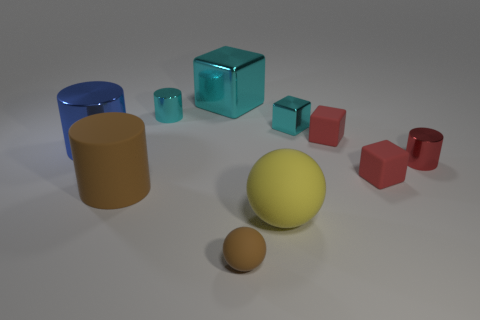Subtract all red cylinders. How many red blocks are left? 2 Subtract 2 cubes. How many cubes are left? 2 Subtract all brown cylinders. How many cylinders are left? 3 Subtract all cyan shiny cylinders. How many cylinders are left? 3 Subtract all green cylinders. Subtract all gray balls. How many cylinders are left? 4 Subtract all balls. How many objects are left? 8 Add 1 tiny cyan metal cylinders. How many tiny cyan metal cylinders exist? 2 Subtract 0 gray cylinders. How many objects are left? 10 Subtract all large cyan metal things. Subtract all small brown rubber things. How many objects are left? 8 Add 9 rubber cylinders. How many rubber cylinders are left? 10 